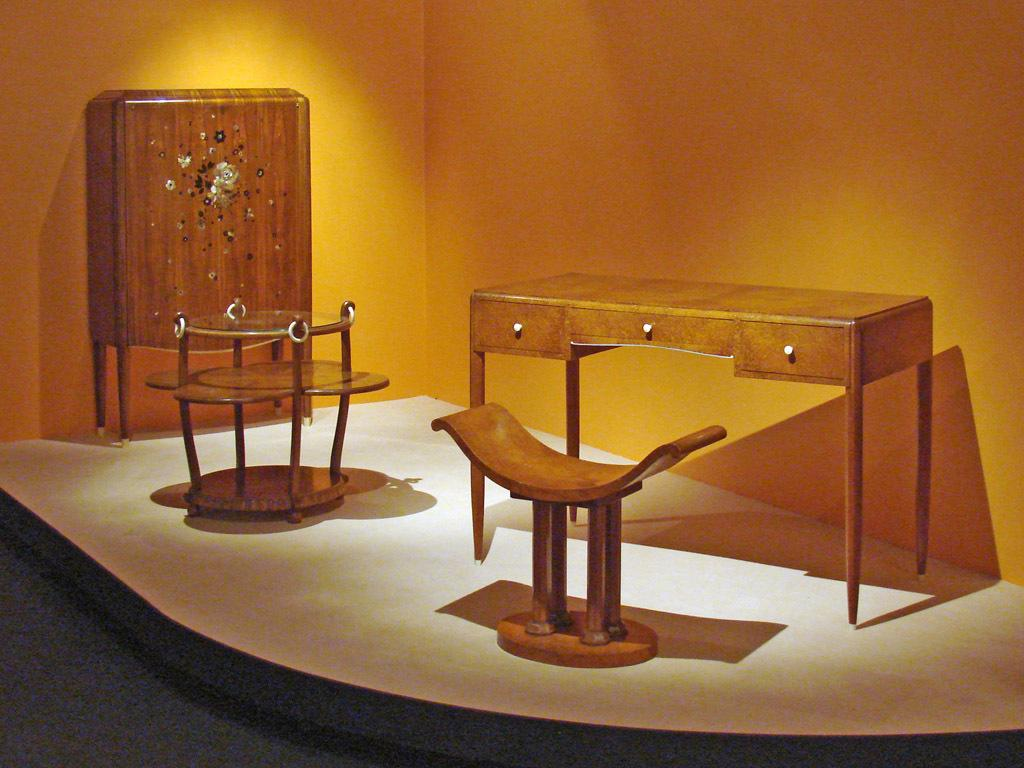What piece of furniture is in the middle of the image? There is a table in the image. What is located on the floor in front of the table? There is a stool on the floor in front of the table. What other piece of furniture can be seen on the left side of the image? There is another table on the left side of the image. What type of material is used for the furniture in the image? There is wooden furniture visible in the image. What is visible in the background of the image? There is a wall in the background of the image. What type of oven can be seen in the image? There is no oven present in the image. 